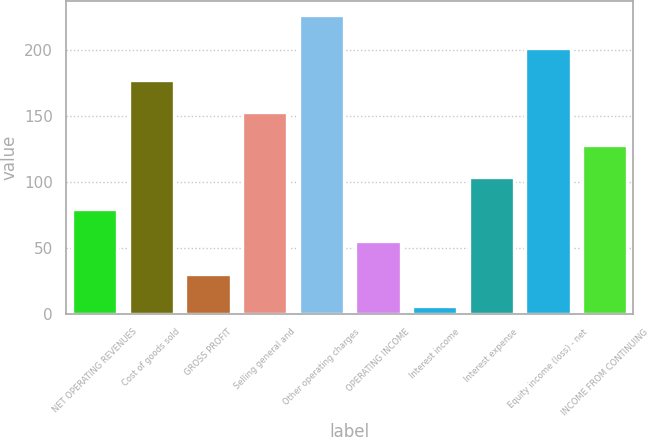Convert chart to OTSL. <chart><loc_0><loc_0><loc_500><loc_500><bar_chart><fcel>NET OPERATING REVENUES<fcel>Cost of goods sold<fcel>GROSS PROFIT<fcel>Selling general and<fcel>Other operating charges<fcel>OPERATING INCOME<fcel>Interest income<fcel>Interest expense<fcel>Equity income (loss) - net<fcel>INCOME FROM CONTINUING<nl><fcel>79.5<fcel>177.5<fcel>30.5<fcel>153<fcel>226.5<fcel>55<fcel>6<fcel>104<fcel>202<fcel>128.5<nl></chart> 